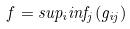<formula> <loc_0><loc_0><loc_500><loc_500>f = s u p _ { i } i n f _ { j } ( g _ { i j } )</formula> 